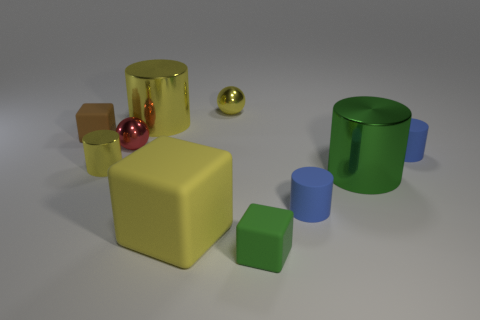What number of other objects are the same size as the brown thing?
Keep it short and to the point. 6. Are there any green metal things that are behind the blue cylinder behind the small shiny object in front of the red metallic ball?
Give a very brief answer. No. Is the material of the green object that is to the right of the small green block the same as the brown block?
Your answer should be very brief. No. What color is the tiny metal object that is the same shape as the big green shiny thing?
Your answer should be very brief. Yellow. Is there any other thing that is the same shape as the large matte object?
Offer a terse response. Yes. Are there an equal number of yellow shiny cylinders that are in front of the red shiny ball and yellow rubber objects?
Provide a succinct answer. Yes. There is a small brown thing; are there any small matte cylinders in front of it?
Your answer should be compact. Yes. How big is the shiny thing that is right of the tiny object that is behind the small rubber object that is to the left of the big yellow block?
Keep it short and to the point. Large. Is the shape of the small thing that is in front of the big yellow block the same as the yellow thing to the right of the yellow block?
Offer a very short reply. No. What size is the other metal thing that is the same shape as the small red object?
Offer a very short reply. Small. 